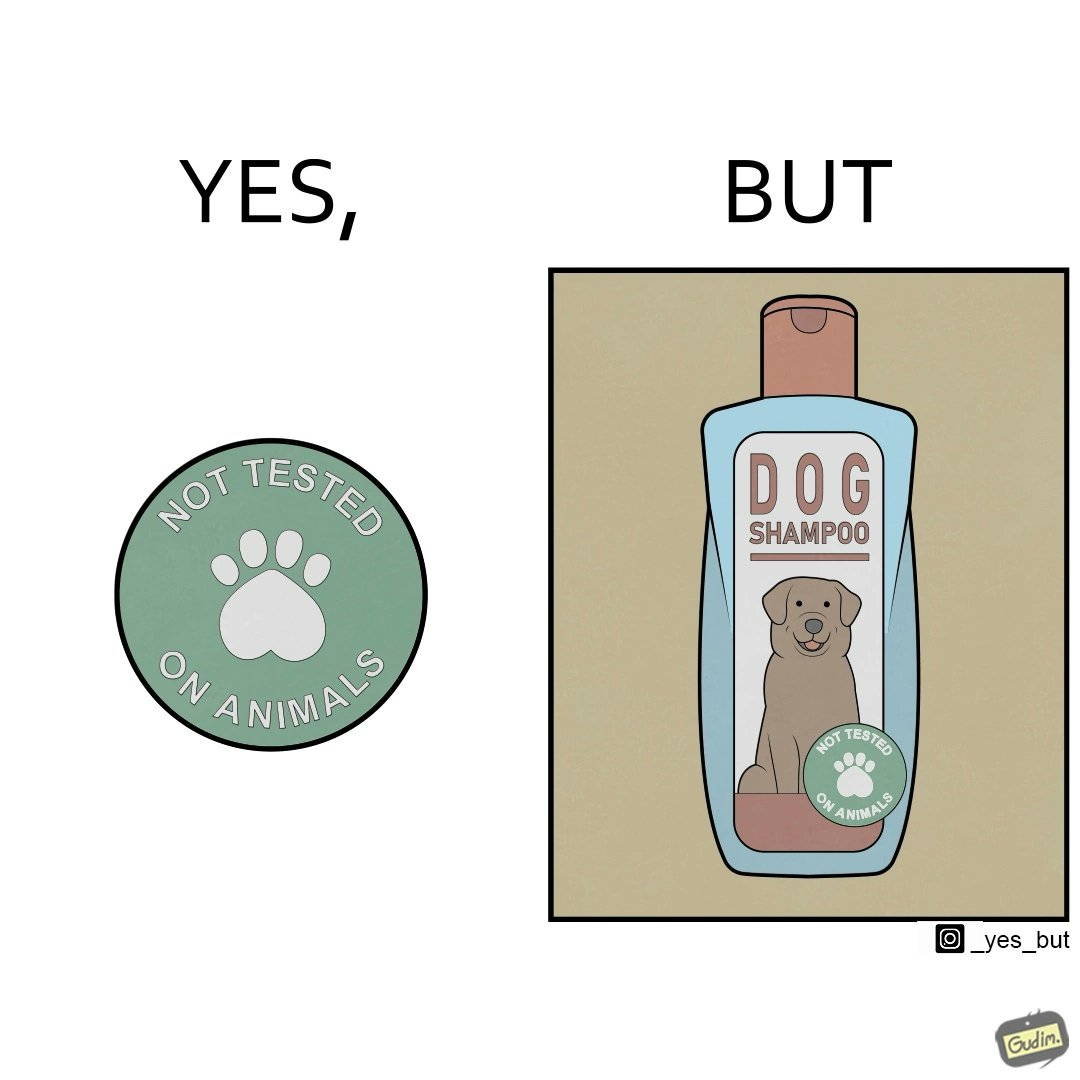Is there satirical content in this image? Yes, this image is satirical. 